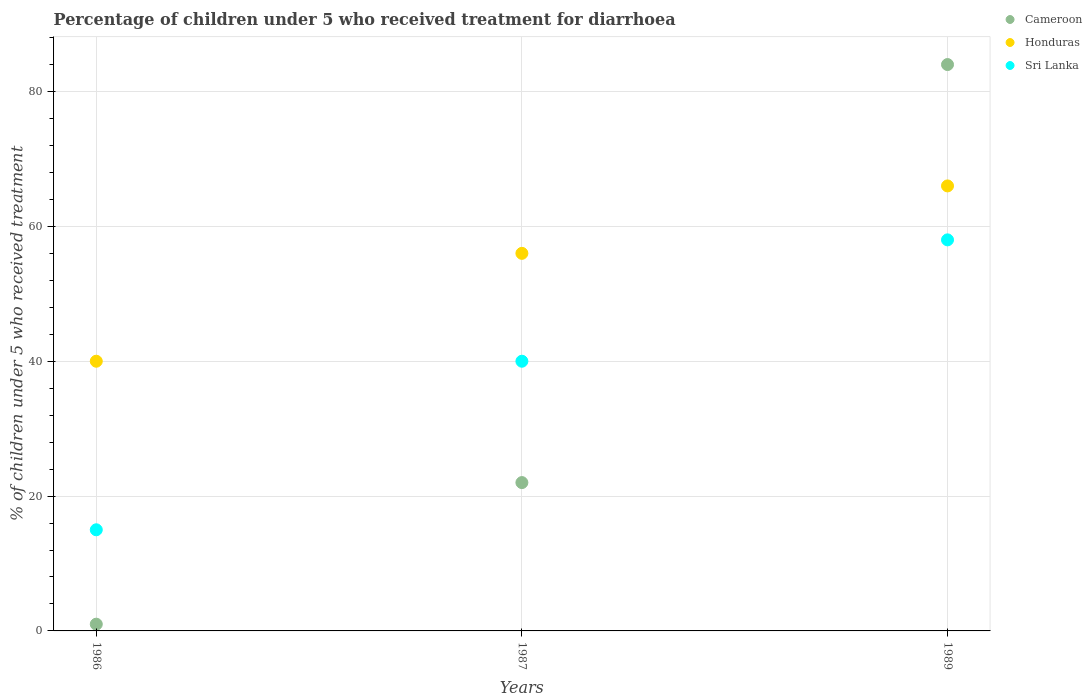Is the number of dotlines equal to the number of legend labels?
Your response must be concise. Yes. In which year was the percentage of children who received treatment for diarrhoea  in Honduras maximum?
Ensure brevity in your answer.  1989. In which year was the percentage of children who received treatment for diarrhoea  in Sri Lanka minimum?
Your answer should be very brief. 1986. What is the total percentage of children who received treatment for diarrhoea  in Cameroon in the graph?
Keep it short and to the point. 107. What is the difference between the percentage of children who received treatment for diarrhoea  in Sri Lanka in 1986 and that in 1987?
Your answer should be very brief. -25. What is the difference between the percentage of children who received treatment for diarrhoea  in Cameroon in 1989 and the percentage of children who received treatment for diarrhoea  in Sri Lanka in 1986?
Provide a succinct answer. 69. What is the average percentage of children who received treatment for diarrhoea  in Sri Lanka per year?
Offer a very short reply. 37.67. In the year 1986, what is the difference between the percentage of children who received treatment for diarrhoea  in Honduras and percentage of children who received treatment for diarrhoea  in Cameroon?
Offer a terse response. 39. In how many years, is the percentage of children who received treatment for diarrhoea  in Sri Lanka greater than 20 %?
Offer a very short reply. 2. What is the ratio of the percentage of children who received treatment for diarrhoea  in Honduras in 1986 to that in 1987?
Your answer should be very brief. 0.71. Is the percentage of children who received treatment for diarrhoea  in Sri Lanka in 1986 less than that in 1987?
Provide a succinct answer. Yes. Is the difference between the percentage of children who received treatment for diarrhoea  in Honduras in 1986 and 1987 greater than the difference between the percentage of children who received treatment for diarrhoea  in Cameroon in 1986 and 1987?
Your answer should be compact. Yes. In how many years, is the percentage of children who received treatment for diarrhoea  in Cameroon greater than the average percentage of children who received treatment for diarrhoea  in Cameroon taken over all years?
Provide a short and direct response. 1. Is the percentage of children who received treatment for diarrhoea  in Honduras strictly greater than the percentage of children who received treatment for diarrhoea  in Cameroon over the years?
Offer a very short reply. No. Is the percentage of children who received treatment for diarrhoea  in Cameroon strictly less than the percentage of children who received treatment for diarrhoea  in Sri Lanka over the years?
Offer a terse response. No. How many dotlines are there?
Your answer should be compact. 3. Are the values on the major ticks of Y-axis written in scientific E-notation?
Ensure brevity in your answer.  No. How are the legend labels stacked?
Your answer should be very brief. Vertical. What is the title of the graph?
Offer a very short reply. Percentage of children under 5 who received treatment for diarrhoea. Does "Nigeria" appear as one of the legend labels in the graph?
Your response must be concise. No. What is the label or title of the X-axis?
Provide a short and direct response. Years. What is the label or title of the Y-axis?
Offer a very short reply. % of children under 5 who received treatment. What is the % of children under 5 who received treatment in Honduras in 1986?
Ensure brevity in your answer.  40. What is the % of children under 5 who received treatment of Honduras in 1987?
Your answer should be compact. 56. What is the % of children under 5 who received treatment in Sri Lanka in 1987?
Your response must be concise. 40. What is the % of children under 5 who received treatment of Cameroon in 1989?
Offer a very short reply. 84. What is the % of children under 5 who received treatment of Sri Lanka in 1989?
Offer a very short reply. 58. Across all years, what is the maximum % of children under 5 who received treatment in Cameroon?
Give a very brief answer. 84. Across all years, what is the maximum % of children under 5 who received treatment in Sri Lanka?
Give a very brief answer. 58. What is the total % of children under 5 who received treatment of Cameroon in the graph?
Make the answer very short. 107. What is the total % of children under 5 who received treatment in Honduras in the graph?
Ensure brevity in your answer.  162. What is the total % of children under 5 who received treatment of Sri Lanka in the graph?
Keep it short and to the point. 113. What is the difference between the % of children under 5 who received treatment in Sri Lanka in 1986 and that in 1987?
Provide a short and direct response. -25. What is the difference between the % of children under 5 who received treatment of Cameroon in 1986 and that in 1989?
Your answer should be compact. -83. What is the difference between the % of children under 5 who received treatment of Sri Lanka in 1986 and that in 1989?
Your response must be concise. -43. What is the difference between the % of children under 5 who received treatment in Cameroon in 1987 and that in 1989?
Make the answer very short. -62. What is the difference between the % of children under 5 who received treatment of Sri Lanka in 1987 and that in 1989?
Provide a short and direct response. -18. What is the difference between the % of children under 5 who received treatment of Cameroon in 1986 and the % of children under 5 who received treatment of Honduras in 1987?
Keep it short and to the point. -55. What is the difference between the % of children under 5 who received treatment in Cameroon in 1986 and the % of children under 5 who received treatment in Sri Lanka in 1987?
Give a very brief answer. -39. What is the difference between the % of children under 5 who received treatment in Cameroon in 1986 and the % of children under 5 who received treatment in Honduras in 1989?
Your response must be concise. -65. What is the difference between the % of children under 5 who received treatment of Cameroon in 1986 and the % of children under 5 who received treatment of Sri Lanka in 1989?
Ensure brevity in your answer.  -57. What is the difference between the % of children under 5 who received treatment in Cameroon in 1987 and the % of children under 5 who received treatment in Honduras in 1989?
Give a very brief answer. -44. What is the difference between the % of children under 5 who received treatment in Cameroon in 1987 and the % of children under 5 who received treatment in Sri Lanka in 1989?
Keep it short and to the point. -36. What is the difference between the % of children under 5 who received treatment of Honduras in 1987 and the % of children under 5 who received treatment of Sri Lanka in 1989?
Offer a terse response. -2. What is the average % of children under 5 who received treatment in Cameroon per year?
Give a very brief answer. 35.67. What is the average % of children under 5 who received treatment of Honduras per year?
Ensure brevity in your answer.  54. What is the average % of children under 5 who received treatment in Sri Lanka per year?
Your response must be concise. 37.67. In the year 1986, what is the difference between the % of children under 5 who received treatment of Cameroon and % of children under 5 who received treatment of Honduras?
Offer a very short reply. -39. In the year 1986, what is the difference between the % of children under 5 who received treatment of Honduras and % of children under 5 who received treatment of Sri Lanka?
Keep it short and to the point. 25. In the year 1987, what is the difference between the % of children under 5 who received treatment of Cameroon and % of children under 5 who received treatment of Honduras?
Provide a succinct answer. -34. In the year 1987, what is the difference between the % of children under 5 who received treatment in Cameroon and % of children under 5 who received treatment in Sri Lanka?
Ensure brevity in your answer.  -18. What is the ratio of the % of children under 5 who received treatment in Cameroon in 1986 to that in 1987?
Offer a terse response. 0.05. What is the ratio of the % of children under 5 who received treatment of Honduras in 1986 to that in 1987?
Give a very brief answer. 0.71. What is the ratio of the % of children under 5 who received treatment of Sri Lanka in 1986 to that in 1987?
Your response must be concise. 0.38. What is the ratio of the % of children under 5 who received treatment in Cameroon in 1986 to that in 1989?
Give a very brief answer. 0.01. What is the ratio of the % of children under 5 who received treatment of Honduras in 1986 to that in 1989?
Provide a short and direct response. 0.61. What is the ratio of the % of children under 5 who received treatment of Sri Lanka in 1986 to that in 1989?
Keep it short and to the point. 0.26. What is the ratio of the % of children under 5 who received treatment in Cameroon in 1987 to that in 1989?
Provide a short and direct response. 0.26. What is the ratio of the % of children under 5 who received treatment in Honduras in 1987 to that in 1989?
Ensure brevity in your answer.  0.85. What is the ratio of the % of children under 5 who received treatment of Sri Lanka in 1987 to that in 1989?
Your answer should be very brief. 0.69. What is the difference between the highest and the second highest % of children under 5 who received treatment in Sri Lanka?
Give a very brief answer. 18. What is the difference between the highest and the lowest % of children under 5 who received treatment in Cameroon?
Your answer should be very brief. 83. What is the difference between the highest and the lowest % of children under 5 who received treatment of Sri Lanka?
Provide a short and direct response. 43. 